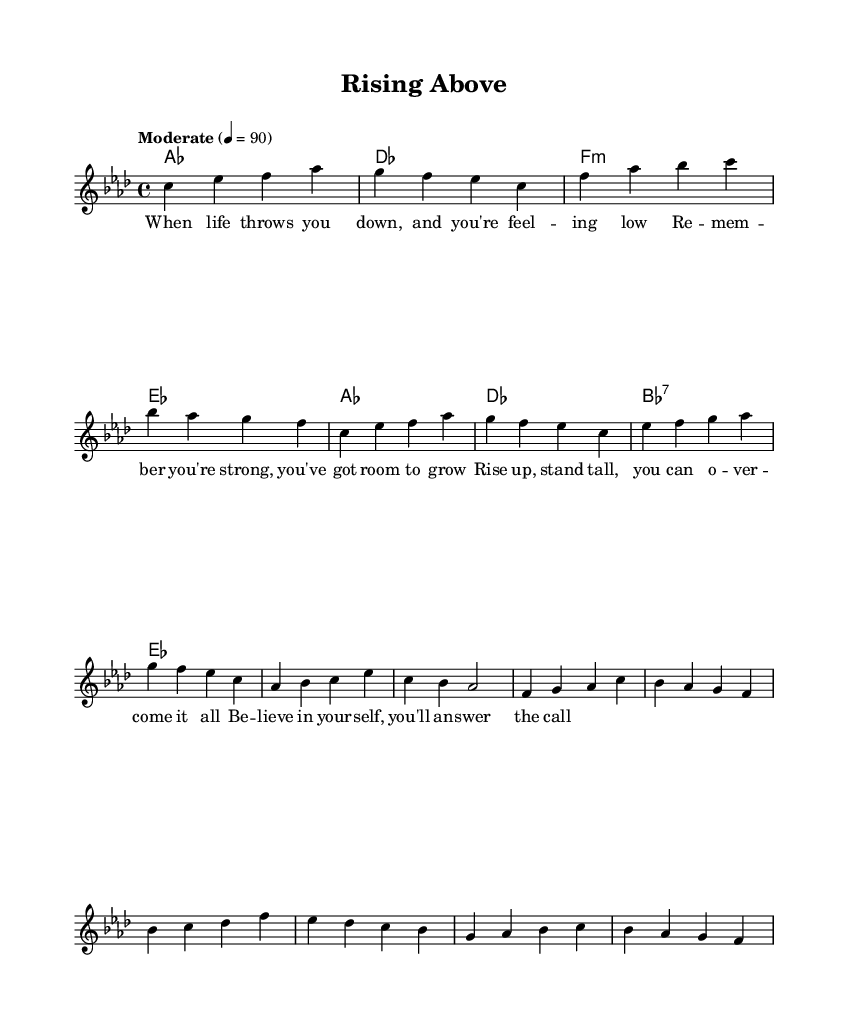What is the key signature of this music? The key signature is indicated by the numbers of sharps or flats at the beginning of the staff. In this case, the music is in A-flat major, which has four flats: B-flat, E-flat, A-flat, and D-flat.
Answer: A-flat major What is the time signature of this music? The time signature is shown at the beginning of the staff and tells you how many beats are in each measure and what note gets the beat. Here, the time signature is 4/4, which means there are four beats in a measure and the quarter note gets one beat.
Answer: 4/4 What is the tempo marking for the piece? The tempo marking indicates the speed of the piece, typically found near the beginning of the music. It states "Moderate" with a metronome marking of 90 beats per minute, indicating a moderate pace.
Answer: Moderate, 90 How many measures are in the verse section? The verse section appears at the beginning of the piece and can be counted by the number of measures indicated by the endings of the lines in the melody. There are four measures in the verse.
Answer: 4 What is the primary theme conveyed in the lyrics? The lyrics express themes of resilience and hope, urging the listener to overcome challenges and believe in themselves. The repeated message throughout the verse and chorus reflects these uplifting sentiments.
Answer: Resilience and hope What type of chords are used in the verse? In the verse, the chords used are A-flat major, D-flat major, F minor, and E-flat major. This combination represents a common progression found in soul music, complementing the uplifting message of the lyrics.
Answer: A-flat major, D-flat major, F minor, E-flat major How does the song’s structure reflect typical soul music patterns? The song follows a common structure of verse and chorus, where the verse sets up an emotional narrative, and the chorus provides a powerful, memorable uplifting message. This mirrors classic 70s soul works that emphasize hope and strength.
Answer: Verse and chorus structure 